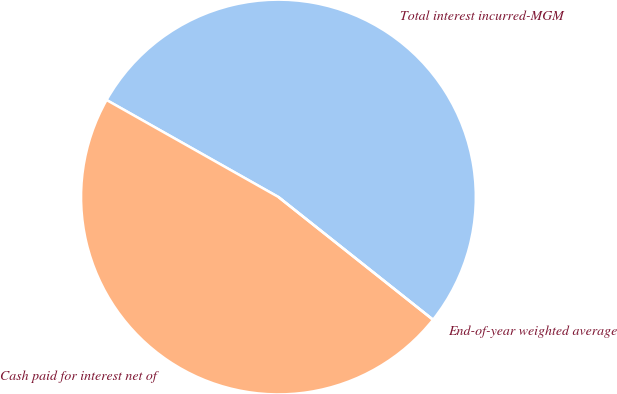Convert chart. <chart><loc_0><loc_0><loc_500><loc_500><pie_chart><fcel>Total interest incurred-MGM<fcel>Cash paid for interest net of<fcel>End-of-year weighted average<nl><fcel>52.5%<fcel>47.5%<fcel>0.0%<nl></chart> 